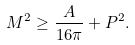Convert formula to latex. <formula><loc_0><loc_0><loc_500><loc_500>M ^ { 2 } \geq \frac { A } { 1 6 \pi } + P ^ { 2 } .</formula> 